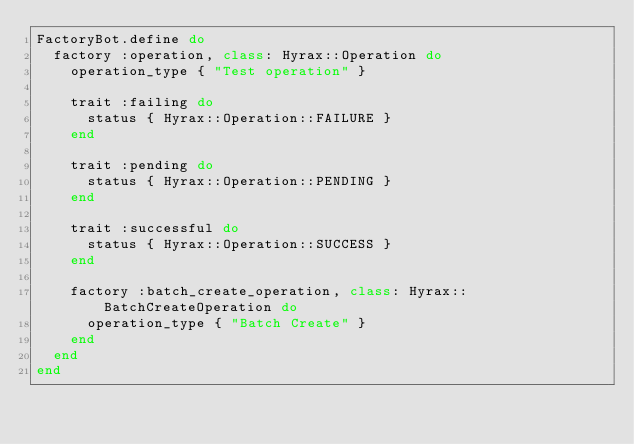<code> <loc_0><loc_0><loc_500><loc_500><_Ruby_>FactoryBot.define do
  factory :operation, class: Hyrax::Operation do
    operation_type { "Test operation" }

    trait :failing do
      status { Hyrax::Operation::FAILURE }
    end

    trait :pending do
      status { Hyrax::Operation::PENDING }
    end

    trait :successful do
      status { Hyrax::Operation::SUCCESS }
    end

    factory :batch_create_operation, class: Hyrax::BatchCreateOperation do
      operation_type { "Batch Create" }
    end
  end
end
</code> 